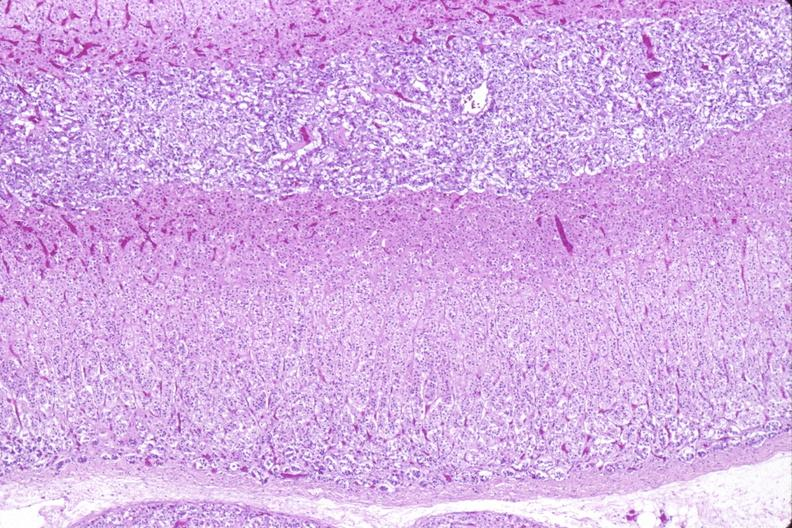where is this part in the figure?
Answer the question using a single word or phrase. Endocrine system 